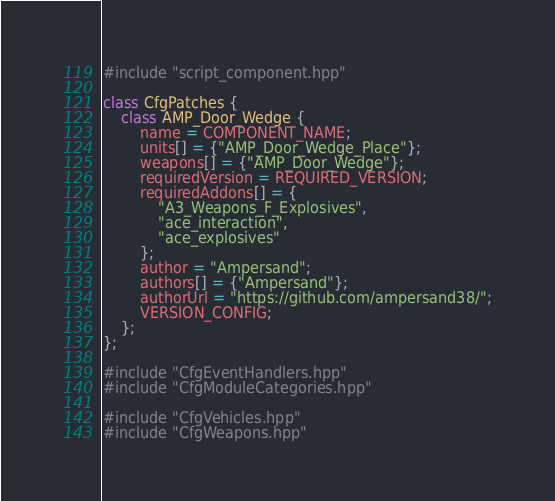Convert code to text. <code><loc_0><loc_0><loc_500><loc_500><_C++_>#include "script_component.hpp"

class CfgPatches {
    class AMP_Door_Wedge {
        name = COMPONENT_NAME;
        units[] = {"AMP_Door_Wedge_Place"};
        weapons[] = {"AMP_Door_Wedge"};
        requiredVersion = REQUIRED_VERSION;
        requiredAddons[] = {
            "A3_Weapons_F_Explosives",
            "ace_interaction",
            "ace_explosives"
        };
        author = "Ampersand";
        authors[] = {"Ampersand"};
        authorUrl = "https://github.com/ampersand38/";
        VERSION_CONFIG;
    };
};

#include "CfgEventHandlers.hpp"
#include "CfgModuleCategories.hpp"

#include "CfgVehicles.hpp"
#include "CfgWeapons.hpp"
</code> 